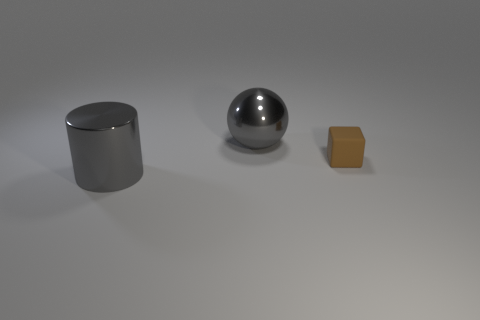Are the tiny brown cube and the big gray thing on the right side of the shiny cylinder made of the same material?
Give a very brief answer. No. What is the large gray sphere made of?
Your response must be concise. Metal. What shape is the big thing that is the same material as the sphere?
Your answer should be very brief. Cylinder. What number of other things are there of the same shape as the tiny matte object?
Your answer should be compact. 0. What number of cylinders are on the right side of the matte cube?
Offer a terse response. 0. Do the gray cylinder that is on the left side of the brown matte cube and the gray thing behind the tiny object have the same size?
Make the answer very short. Yes. What number of other things are the same size as the brown matte thing?
Provide a succinct answer. 0. There is a big object that is to the right of the gray shiny object in front of the big metal object behind the cylinder; what is it made of?
Give a very brief answer. Metal. There is a matte thing; is it the same size as the gray thing behind the tiny brown cube?
Provide a succinct answer. No. What size is the thing that is in front of the gray metallic sphere and left of the tiny brown block?
Provide a short and direct response. Large. 